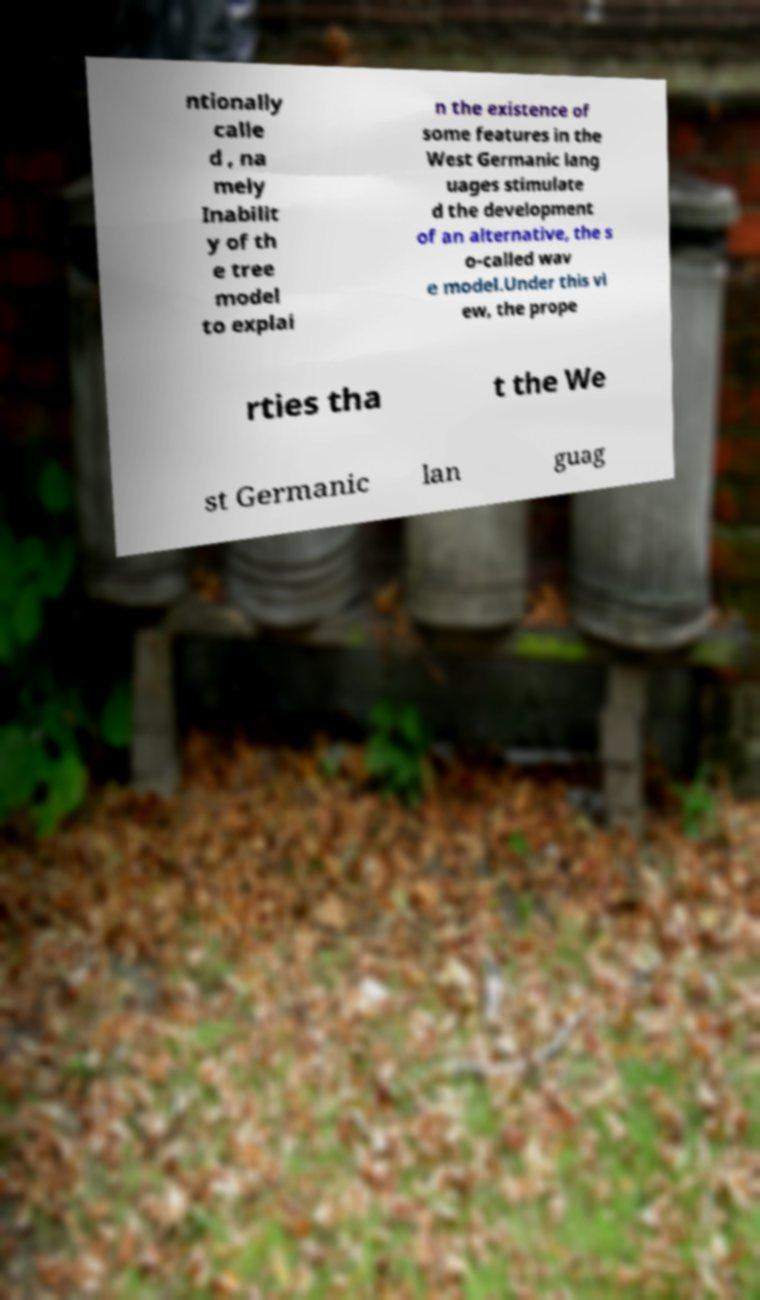Please read and relay the text visible in this image. What does it say? ntionally calle d , na mely Inabilit y of th e tree model to explai n the existence of some features in the West Germanic lang uages stimulate d the development of an alternative, the s o-called wav e model.Under this vi ew, the prope rties tha t the We st Germanic lan guag 